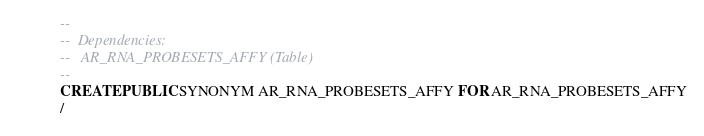Convert code to text. <code><loc_0><loc_0><loc_500><loc_500><_SQL_>--
--  Dependencies: 
--   AR_RNA_PROBESETS_AFFY (Table)
--
CREATE PUBLIC SYNONYM AR_RNA_PROBESETS_AFFY FOR AR_RNA_PROBESETS_AFFY
/


</code> 